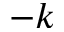<formula> <loc_0><loc_0><loc_500><loc_500>- k</formula> 